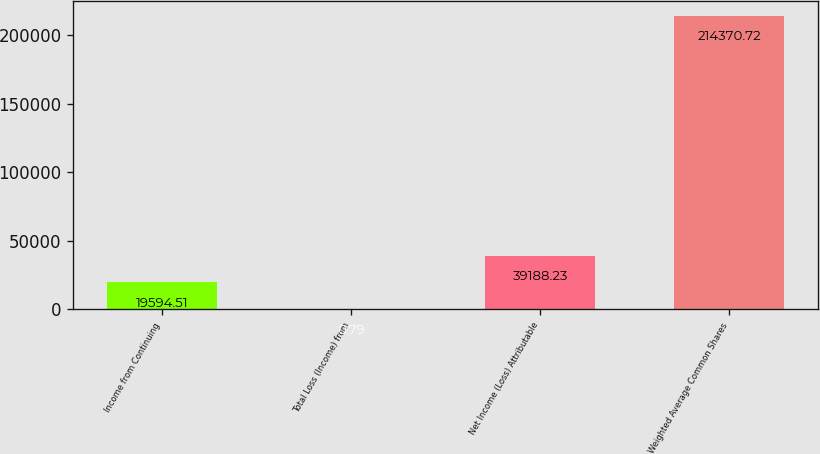Convert chart. <chart><loc_0><loc_0><loc_500><loc_500><bar_chart><fcel>Income from Continuing<fcel>Total Loss (Income) from<fcel>Net Income (Loss) Attributable<fcel>Weighted Average Common Shares<nl><fcel>19594.5<fcel>0.79<fcel>39188.2<fcel>214371<nl></chart> 